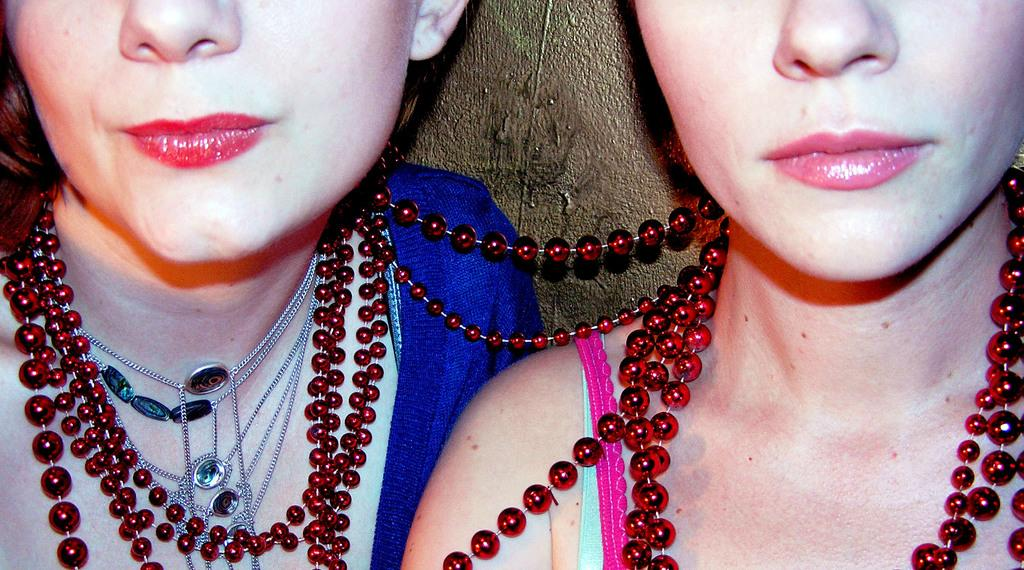How many people are in the image? There are two women in the image. What are the women wearing in the image? The women are wearing necklaces in the image. What type of agreement did the dogs reach in the image? There are no dogs present in the image, so there is no agreement to discuss. 